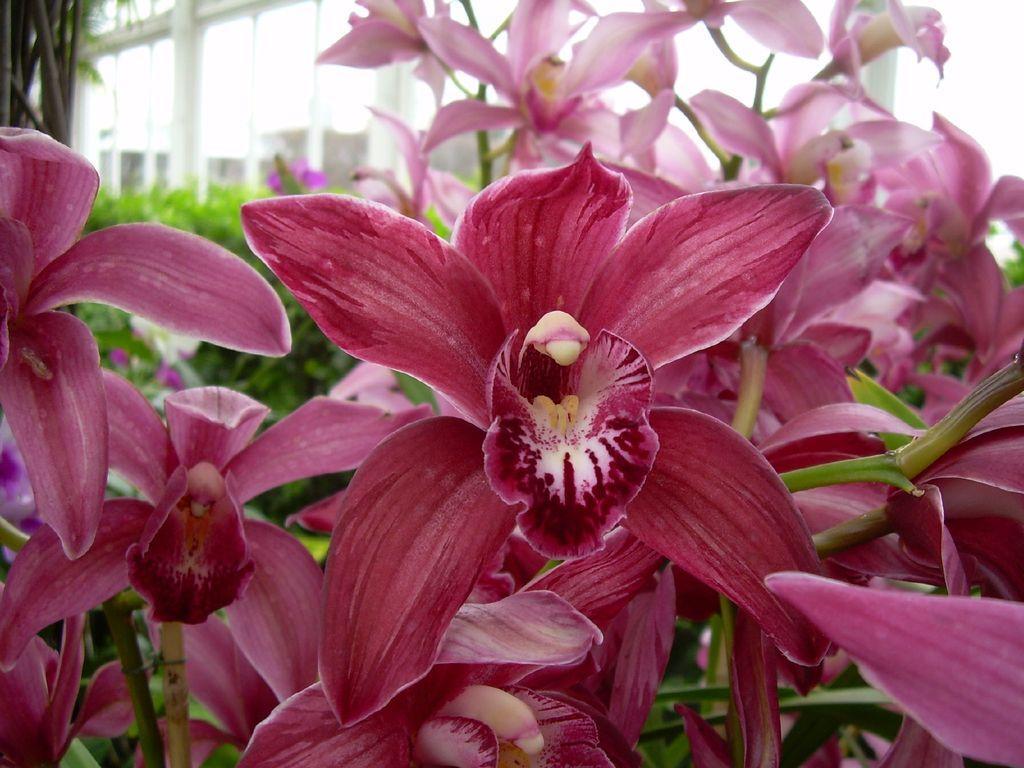Describe this image in one or two sentences. This picture is taken outside and In the foreground of this picture, we see pink colored flowers and in the background, there are plants, a tree and the building. 